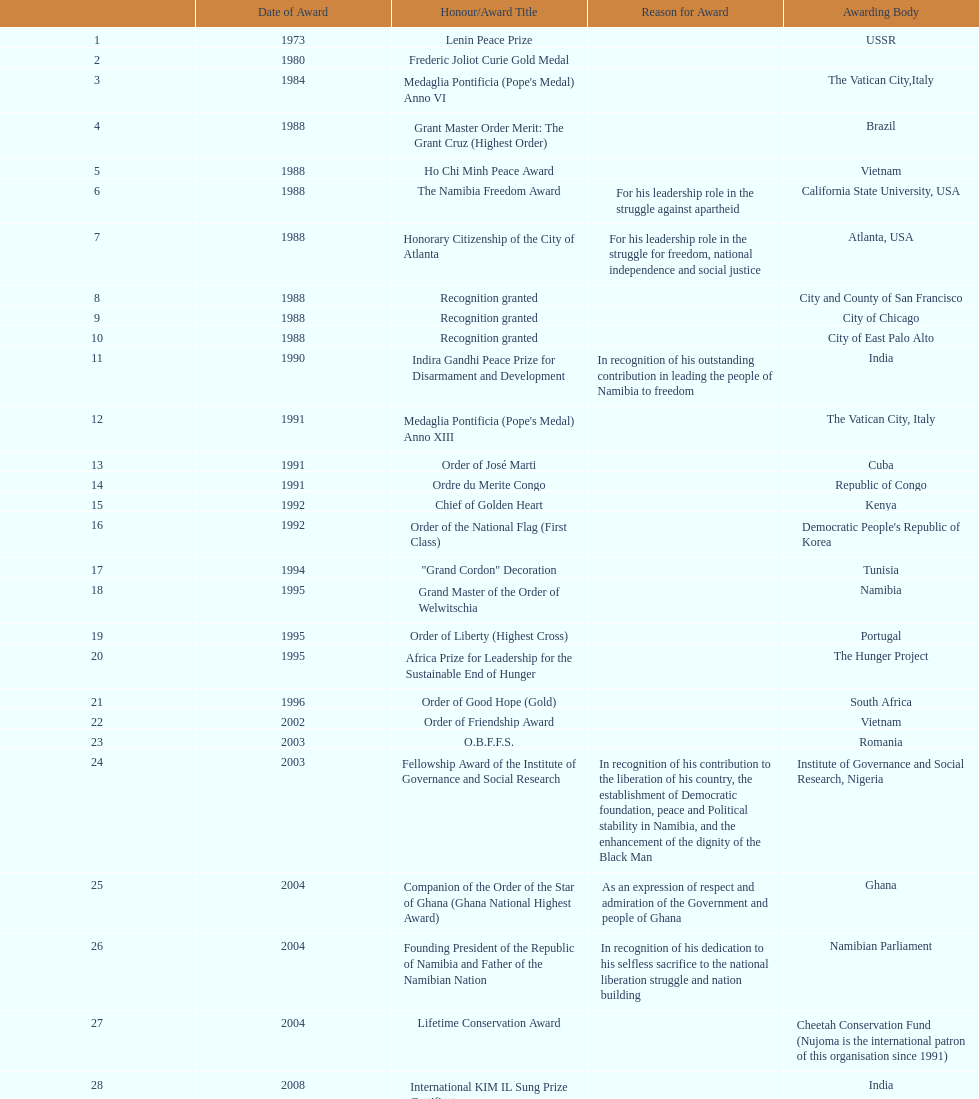What is the newest award nujoma has acquired? Sir Seretse Khama SADC Meda. 